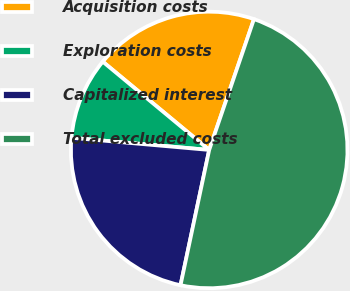Convert chart. <chart><loc_0><loc_0><loc_500><loc_500><pie_chart><fcel>Acquisition costs<fcel>Exploration costs<fcel>Capitalized interest<fcel>Total excluded costs<nl><fcel>19.23%<fcel>9.62%<fcel>23.08%<fcel>48.08%<nl></chart> 